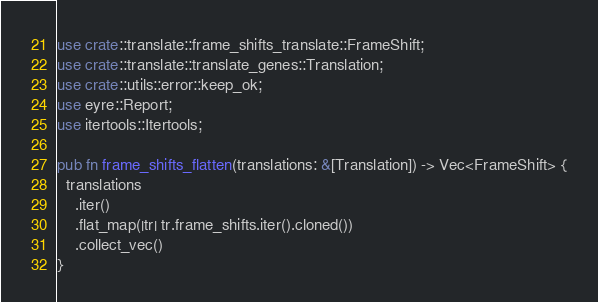Convert code to text. <code><loc_0><loc_0><loc_500><loc_500><_Rust_>use crate::translate::frame_shifts_translate::FrameShift;
use crate::translate::translate_genes::Translation;
use crate::utils::error::keep_ok;
use eyre::Report;
use itertools::Itertools;

pub fn frame_shifts_flatten(translations: &[Translation]) -> Vec<FrameShift> {
  translations
    .iter()
    .flat_map(|tr| tr.frame_shifts.iter().cloned())
    .collect_vec()
}
</code> 